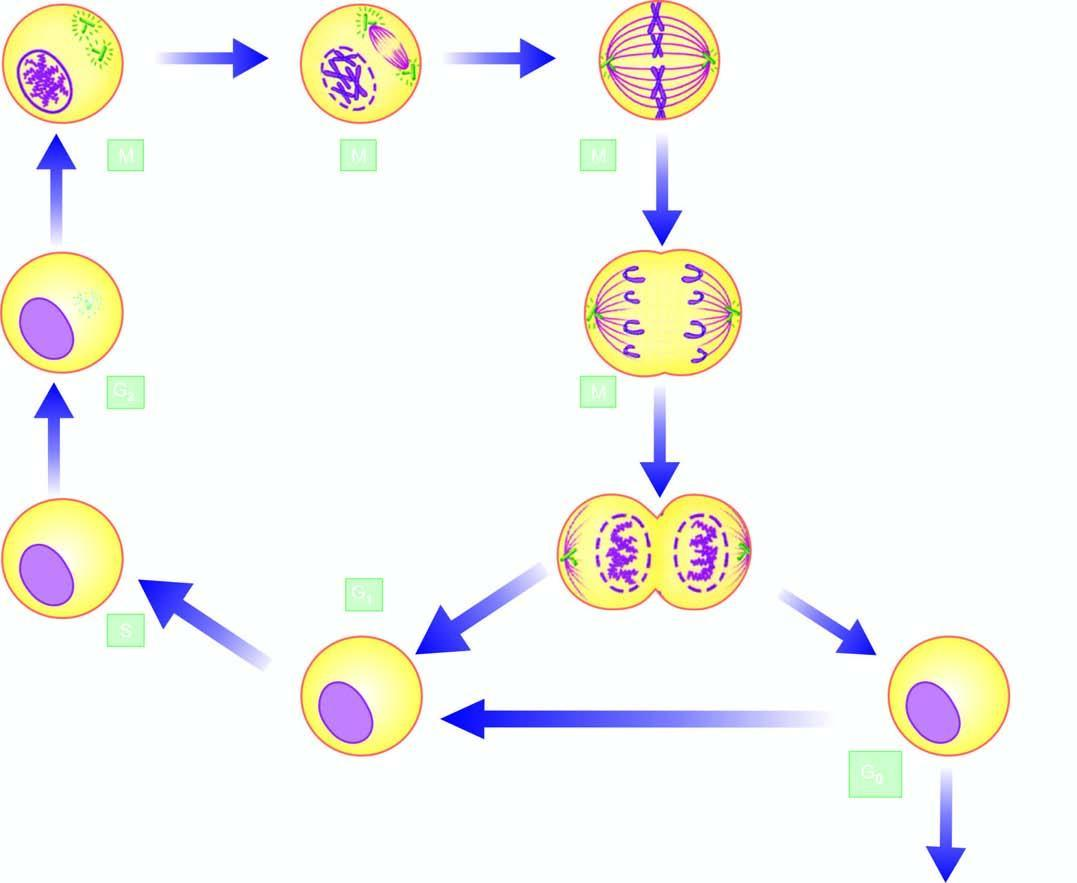what are formed which may continue to remain in the cell cycle or go out of it in resting phase interphase, the g0 phase on completion of cell division?
Answer the question using a single word or phrase. Two daughter cells 